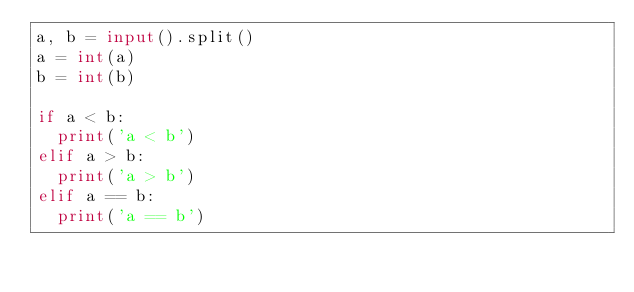Convert code to text. <code><loc_0><loc_0><loc_500><loc_500><_Python_>a, b = input().split()
a = int(a)
b = int(b)

if a < b:
  print('a < b')
elif a > b:
  print('a > b')
elif a == b:
  print('a == b')
</code> 